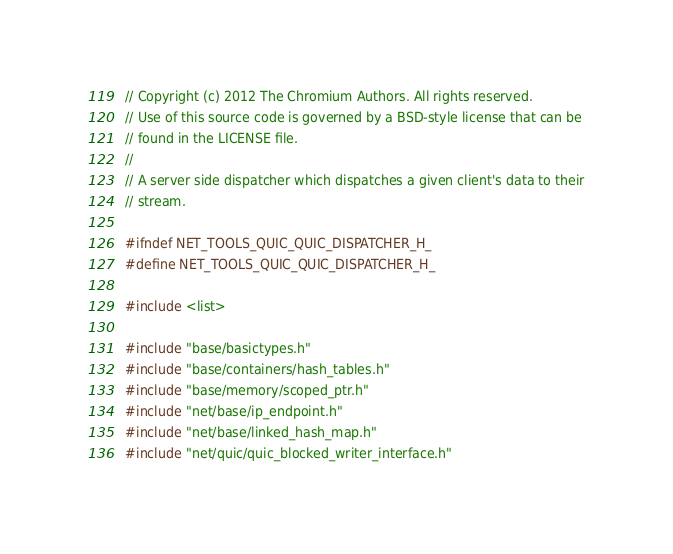Convert code to text. <code><loc_0><loc_0><loc_500><loc_500><_C_>// Copyright (c) 2012 The Chromium Authors. All rights reserved.
// Use of this source code is governed by a BSD-style license that can be
// found in the LICENSE file.
//
// A server side dispatcher which dispatches a given client's data to their
// stream.

#ifndef NET_TOOLS_QUIC_QUIC_DISPATCHER_H_
#define NET_TOOLS_QUIC_QUIC_DISPATCHER_H_

#include <list>

#include "base/basictypes.h"
#include "base/containers/hash_tables.h"
#include "base/memory/scoped_ptr.h"
#include "net/base/ip_endpoint.h"
#include "net/base/linked_hash_map.h"
#include "net/quic/quic_blocked_writer_interface.h"</code> 